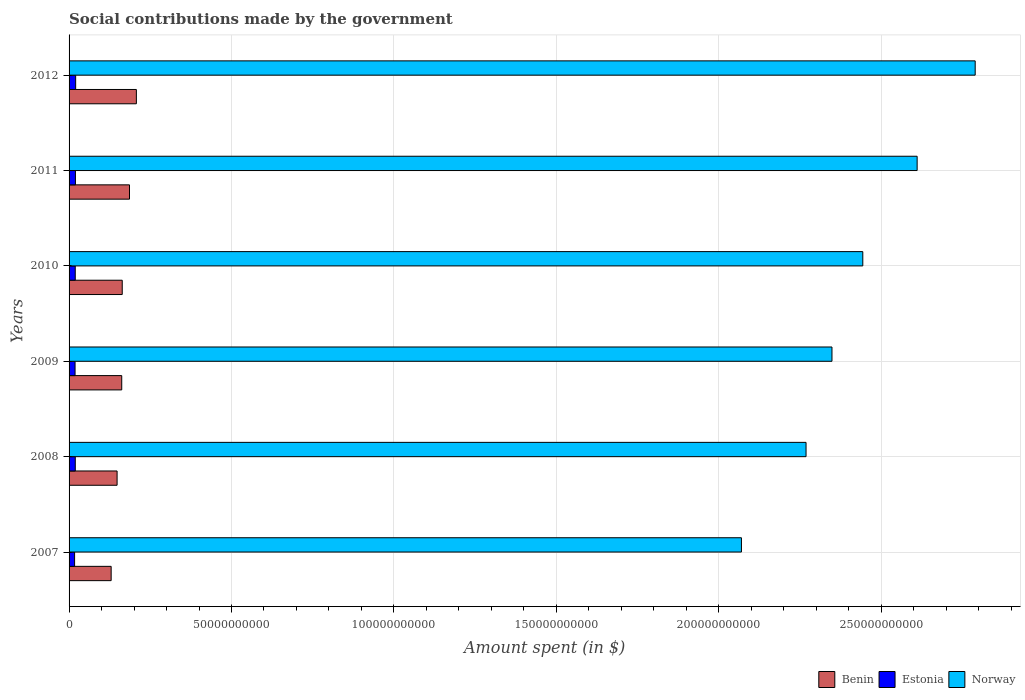Are the number of bars per tick equal to the number of legend labels?
Make the answer very short. Yes. How many bars are there on the 1st tick from the bottom?
Offer a terse response. 3. What is the amount spent on social contributions in Benin in 2007?
Provide a short and direct response. 1.30e+1. Across all years, what is the maximum amount spent on social contributions in Norway?
Your answer should be very brief. 2.79e+11. Across all years, what is the minimum amount spent on social contributions in Norway?
Your answer should be very brief. 2.07e+11. In which year was the amount spent on social contributions in Benin maximum?
Your response must be concise. 2012. What is the total amount spent on social contributions in Norway in the graph?
Ensure brevity in your answer.  1.45e+12. What is the difference between the amount spent on social contributions in Estonia in 2008 and that in 2009?
Give a very brief answer. 6.94e+07. What is the difference between the amount spent on social contributions in Norway in 2010 and the amount spent on social contributions in Estonia in 2011?
Make the answer very short. 2.42e+11. What is the average amount spent on social contributions in Benin per year?
Make the answer very short. 1.66e+1. In the year 2009, what is the difference between the amount spent on social contributions in Benin and amount spent on social contributions in Estonia?
Offer a very short reply. 1.44e+1. What is the ratio of the amount spent on social contributions in Benin in 2008 to that in 2009?
Your answer should be very brief. 0.91. Is the difference between the amount spent on social contributions in Benin in 2008 and 2010 greater than the difference between the amount spent on social contributions in Estonia in 2008 and 2010?
Your response must be concise. No. What is the difference between the highest and the second highest amount spent on social contributions in Estonia?
Your response must be concise. 6.76e+07. What is the difference between the highest and the lowest amount spent on social contributions in Benin?
Provide a succinct answer. 7.76e+09. In how many years, is the amount spent on social contributions in Estonia greater than the average amount spent on social contributions in Estonia taken over all years?
Offer a terse response. 4. Is the sum of the amount spent on social contributions in Benin in 2010 and 2011 greater than the maximum amount spent on social contributions in Norway across all years?
Offer a very short reply. No. What does the 2nd bar from the top in 2009 represents?
Your response must be concise. Estonia. How many years are there in the graph?
Your answer should be compact. 6. What is the difference between two consecutive major ticks on the X-axis?
Your answer should be very brief. 5.00e+1. Are the values on the major ticks of X-axis written in scientific E-notation?
Offer a very short reply. No. Does the graph contain any zero values?
Your response must be concise. No. How many legend labels are there?
Provide a short and direct response. 3. What is the title of the graph?
Offer a terse response. Social contributions made by the government. What is the label or title of the X-axis?
Your response must be concise. Amount spent (in $). What is the Amount spent (in $) in Benin in 2007?
Give a very brief answer. 1.30e+1. What is the Amount spent (in $) in Estonia in 2007?
Your answer should be compact. 1.70e+09. What is the Amount spent (in $) of Norway in 2007?
Make the answer very short. 2.07e+11. What is the Amount spent (in $) in Benin in 2008?
Keep it short and to the point. 1.48e+1. What is the Amount spent (in $) in Estonia in 2008?
Offer a very short reply. 1.91e+09. What is the Amount spent (in $) in Norway in 2008?
Keep it short and to the point. 2.27e+11. What is the Amount spent (in $) of Benin in 2009?
Ensure brevity in your answer.  1.62e+1. What is the Amount spent (in $) in Estonia in 2009?
Offer a terse response. 1.84e+09. What is the Amount spent (in $) of Norway in 2009?
Provide a succinct answer. 2.35e+11. What is the Amount spent (in $) in Benin in 2010?
Offer a very short reply. 1.64e+1. What is the Amount spent (in $) in Estonia in 2010?
Provide a succinct answer. 1.90e+09. What is the Amount spent (in $) of Norway in 2010?
Give a very brief answer. 2.44e+11. What is the Amount spent (in $) in Benin in 2011?
Make the answer very short. 1.86e+1. What is the Amount spent (in $) of Estonia in 2011?
Offer a terse response. 1.96e+09. What is the Amount spent (in $) of Norway in 2011?
Keep it short and to the point. 2.61e+11. What is the Amount spent (in $) of Benin in 2012?
Your answer should be compact. 2.07e+1. What is the Amount spent (in $) in Estonia in 2012?
Your answer should be very brief. 2.03e+09. What is the Amount spent (in $) of Norway in 2012?
Keep it short and to the point. 2.79e+11. Across all years, what is the maximum Amount spent (in $) of Benin?
Provide a short and direct response. 2.07e+1. Across all years, what is the maximum Amount spent (in $) of Estonia?
Offer a very short reply. 2.03e+09. Across all years, what is the maximum Amount spent (in $) of Norway?
Your answer should be compact. 2.79e+11. Across all years, what is the minimum Amount spent (in $) of Benin?
Your response must be concise. 1.30e+1. Across all years, what is the minimum Amount spent (in $) in Estonia?
Ensure brevity in your answer.  1.70e+09. Across all years, what is the minimum Amount spent (in $) in Norway?
Offer a terse response. 2.07e+11. What is the total Amount spent (in $) in Benin in the graph?
Your answer should be compact. 9.96e+1. What is the total Amount spent (in $) of Estonia in the graph?
Keep it short and to the point. 1.13e+1. What is the total Amount spent (in $) in Norway in the graph?
Ensure brevity in your answer.  1.45e+12. What is the difference between the Amount spent (in $) of Benin in 2007 and that in 2008?
Make the answer very short. -1.83e+09. What is the difference between the Amount spent (in $) of Estonia in 2007 and that in 2008?
Your answer should be compact. -2.13e+08. What is the difference between the Amount spent (in $) in Norway in 2007 and that in 2008?
Provide a short and direct response. -1.99e+1. What is the difference between the Amount spent (in $) in Benin in 2007 and that in 2009?
Provide a succinct answer. -3.26e+09. What is the difference between the Amount spent (in $) of Estonia in 2007 and that in 2009?
Offer a terse response. -1.43e+08. What is the difference between the Amount spent (in $) of Norway in 2007 and that in 2009?
Make the answer very short. -2.79e+1. What is the difference between the Amount spent (in $) in Benin in 2007 and that in 2010?
Offer a terse response. -3.41e+09. What is the difference between the Amount spent (in $) of Estonia in 2007 and that in 2010?
Provide a succinct answer. -2.05e+08. What is the difference between the Amount spent (in $) in Norway in 2007 and that in 2010?
Your answer should be very brief. -3.74e+1. What is the difference between the Amount spent (in $) of Benin in 2007 and that in 2011?
Offer a terse response. -5.65e+09. What is the difference between the Amount spent (in $) of Estonia in 2007 and that in 2011?
Your response must be concise. -2.61e+08. What is the difference between the Amount spent (in $) in Norway in 2007 and that in 2011?
Give a very brief answer. -5.41e+1. What is the difference between the Amount spent (in $) of Benin in 2007 and that in 2012?
Offer a terse response. -7.76e+09. What is the difference between the Amount spent (in $) in Estonia in 2007 and that in 2012?
Offer a terse response. -3.29e+08. What is the difference between the Amount spent (in $) in Norway in 2007 and that in 2012?
Ensure brevity in your answer.  -7.20e+1. What is the difference between the Amount spent (in $) in Benin in 2008 and that in 2009?
Ensure brevity in your answer.  -1.43e+09. What is the difference between the Amount spent (in $) of Estonia in 2008 and that in 2009?
Your answer should be compact. 6.94e+07. What is the difference between the Amount spent (in $) of Norway in 2008 and that in 2009?
Your answer should be compact. -7.98e+09. What is the difference between the Amount spent (in $) of Benin in 2008 and that in 2010?
Ensure brevity in your answer.  -1.58e+09. What is the difference between the Amount spent (in $) of Norway in 2008 and that in 2010?
Make the answer very short. -1.75e+1. What is the difference between the Amount spent (in $) in Benin in 2008 and that in 2011?
Provide a succinct answer. -3.82e+09. What is the difference between the Amount spent (in $) in Estonia in 2008 and that in 2011?
Provide a short and direct response. -4.88e+07. What is the difference between the Amount spent (in $) in Norway in 2008 and that in 2011?
Provide a succinct answer. -3.42e+1. What is the difference between the Amount spent (in $) in Benin in 2008 and that in 2012?
Your response must be concise. -5.93e+09. What is the difference between the Amount spent (in $) of Estonia in 2008 and that in 2012?
Ensure brevity in your answer.  -1.16e+08. What is the difference between the Amount spent (in $) of Norway in 2008 and that in 2012?
Your answer should be very brief. -5.21e+1. What is the difference between the Amount spent (in $) in Benin in 2009 and that in 2010?
Make the answer very short. -1.53e+08. What is the difference between the Amount spent (in $) of Estonia in 2009 and that in 2010?
Provide a succinct answer. -6.14e+07. What is the difference between the Amount spent (in $) of Norway in 2009 and that in 2010?
Offer a very short reply. -9.49e+09. What is the difference between the Amount spent (in $) in Benin in 2009 and that in 2011?
Offer a terse response. -2.39e+09. What is the difference between the Amount spent (in $) of Estonia in 2009 and that in 2011?
Offer a terse response. -1.18e+08. What is the difference between the Amount spent (in $) of Norway in 2009 and that in 2011?
Ensure brevity in your answer.  -2.62e+1. What is the difference between the Amount spent (in $) in Benin in 2009 and that in 2012?
Keep it short and to the point. -4.50e+09. What is the difference between the Amount spent (in $) in Estonia in 2009 and that in 2012?
Offer a terse response. -1.86e+08. What is the difference between the Amount spent (in $) of Norway in 2009 and that in 2012?
Your answer should be compact. -4.41e+1. What is the difference between the Amount spent (in $) of Benin in 2010 and that in 2011?
Make the answer very short. -2.24e+09. What is the difference between the Amount spent (in $) of Estonia in 2010 and that in 2011?
Your answer should be very brief. -5.68e+07. What is the difference between the Amount spent (in $) of Norway in 2010 and that in 2011?
Your answer should be compact. -1.67e+1. What is the difference between the Amount spent (in $) in Benin in 2010 and that in 2012?
Provide a succinct answer. -4.35e+09. What is the difference between the Amount spent (in $) in Estonia in 2010 and that in 2012?
Your response must be concise. -1.24e+08. What is the difference between the Amount spent (in $) in Norway in 2010 and that in 2012?
Offer a very short reply. -3.46e+1. What is the difference between the Amount spent (in $) of Benin in 2011 and that in 2012?
Your response must be concise. -2.12e+09. What is the difference between the Amount spent (in $) in Estonia in 2011 and that in 2012?
Make the answer very short. -6.76e+07. What is the difference between the Amount spent (in $) in Norway in 2011 and that in 2012?
Offer a terse response. -1.79e+1. What is the difference between the Amount spent (in $) in Benin in 2007 and the Amount spent (in $) in Estonia in 2008?
Keep it short and to the point. 1.10e+1. What is the difference between the Amount spent (in $) of Benin in 2007 and the Amount spent (in $) of Norway in 2008?
Offer a very short reply. -2.14e+11. What is the difference between the Amount spent (in $) in Estonia in 2007 and the Amount spent (in $) in Norway in 2008?
Ensure brevity in your answer.  -2.25e+11. What is the difference between the Amount spent (in $) in Benin in 2007 and the Amount spent (in $) in Estonia in 2009?
Your answer should be very brief. 1.11e+1. What is the difference between the Amount spent (in $) of Benin in 2007 and the Amount spent (in $) of Norway in 2009?
Your answer should be compact. -2.22e+11. What is the difference between the Amount spent (in $) in Estonia in 2007 and the Amount spent (in $) in Norway in 2009?
Your response must be concise. -2.33e+11. What is the difference between the Amount spent (in $) in Benin in 2007 and the Amount spent (in $) in Estonia in 2010?
Provide a succinct answer. 1.11e+1. What is the difference between the Amount spent (in $) in Benin in 2007 and the Amount spent (in $) in Norway in 2010?
Give a very brief answer. -2.31e+11. What is the difference between the Amount spent (in $) of Estonia in 2007 and the Amount spent (in $) of Norway in 2010?
Your answer should be very brief. -2.43e+11. What is the difference between the Amount spent (in $) of Benin in 2007 and the Amount spent (in $) of Estonia in 2011?
Make the answer very short. 1.10e+1. What is the difference between the Amount spent (in $) of Benin in 2007 and the Amount spent (in $) of Norway in 2011?
Offer a very short reply. -2.48e+11. What is the difference between the Amount spent (in $) in Estonia in 2007 and the Amount spent (in $) in Norway in 2011?
Provide a succinct answer. -2.59e+11. What is the difference between the Amount spent (in $) in Benin in 2007 and the Amount spent (in $) in Estonia in 2012?
Ensure brevity in your answer.  1.09e+1. What is the difference between the Amount spent (in $) in Benin in 2007 and the Amount spent (in $) in Norway in 2012?
Your response must be concise. -2.66e+11. What is the difference between the Amount spent (in $) of Estonia in 2007 and the Amount spent (in $) of Norway in 2012?
Offer a very short reply. -2.77e+11. What is the difference between the Amount spent (in $) in Benin in 2008 and the Amount spent (in $) in Estonia in 2009?
Ensure brevity in your answer.  1.29e+1. What is the difference between the Amount spent (in $) in Benin in 2008 and the Amount spent (in $) in Norway in 2009?
Offer a terse response. -2.20e+11. What is the difference between the Amount spent (in $) of Estonia in 2008 and the Amount spent (in $) of Norway in 2009?
Keep it short and to the point. -2.33e+11. What is the difference between the Amount spent (in $) of Benin in 2008 and the Amount spent (in $) of Estonia in 2010?
Give a very brief answer. 1.29e+1. What is the difference between the Amount spent (in $) in Benin in 2008 and the Amount spent (in $) in Norway in 2010?
Provide a short and direct response. -2.30e+11. What is the difference between the Amount spent (in $) of Estonia in 2008 and the Amount spent (in $) of Norway in 2010?
Ensure brevity in your answer.  -2.42e+11. What is the difference between the Amount spent (in $) of Benin in 2008 and the Amount spent (in $) of Estonia in 2011?
Give a very brief answer. 1.28e+1. What is the difference between the Amount spent (in $) in Benin in 2008 and the Amount spent (in $) in Norway in 2011?
Provide a succinct answer. -2.46e+11. What is the difference between the Amount spent (in $) in Estonia in 2008 and the Amount spent (in $) in Norway in 2011?
Ensure brevity in your answer.  -2.59e+11. What is the difference between the Amount spent (in $) in Benin in 2008 and the Amount spent (in $) in Estonia in 2012?
Your answer should be very brief. 1.28e+1. What is the difference between the Amount spent (in $) in Benin in 2008 and the Amount spent (in $) in Norway in 2012?
Offer a terse response. -2.64e+11. What is the difference between the Amount spent (in $) in Estonia in 2008 and the Amount spent (in $) in Norway in 2012?
Keep it short and to the point. -2.77e+11. What is the difference between the Amount spent (in $) in Benin in 2009 and the Amount spent (in $) in Estonia in 2010?
Provide a short and direct response. 1.43e+1. What is the difference between the Amount spent (in $) in Benin in 2009 and the Amount spent (in $) in Norway in 2010?
Provide a succinct answer. -2.28e+11. What is the difference between the Amount spent (in $) in Estonia in 2009 and the Amount spent (in $) in Norway in 2010?
Your answer should be compact. -2.42e+11. What is the difference between the Amount spent (in $) in Benin in 2009 and the Amount spent (in $) in Estonia in 2011?
Your answer should be very brief. 1.43e+1. What is the difference between the Amount spent (in $) of Benin in 2009 and the Amount spent (in $) of Norway in 2011?
Your answer should be compact. -2.45e+11. What is the difference between the Amount spent (in $) in Estonia in 2009 and the Amount spent (in $) in Norway in 2011?
Provide a succinct answer. -2.59e+11. What is the difference between the Amount spent (in $) in Benin in 2009 and the Amount spent (in $) in Estonia in 2012?
Offer a very short reply. 1.42e+1. What is the difference between the Amount spent (in $) in Benin in 2009 and the Amount spent (in $) in Norway in 2012?
Your answer should be compact. -2.63e+11. What is the difference between the Amount spent (in $) in Estonia in 2009 and the Amount spent (in $) in Norway in 2012?
Your answer should be very brief. -2.77e+11. What is the difference between the Amount spent (in $) of Benin in 2010 and the Amount spent (in $) of Estonia in 2011?
Provide a succinct answer. 1.44e+1. What is the difference between the Amount spent (in $) of Benin in 2010 and the Amount spent (in $) of Norway in 2011?
Ensure brevity in your answer.  -2.45e+11. What is the difference between the Amount spent (in $) in Estonia in 2010 and the Amount spent (in $) in Norway in 2011?
Keep it short and to the point. -2.59e+11. What is the difference between the Amount spent (in $) of Benin in 2010 and the Amount spent (in $) of Estonia in 2012?
Provide a succinct answer. 1.43e+1. What is the difference between the Amount spent (in $) of Benin in 2010 and the Amount spent (in $) of Norway in 2012?
Offer a terse response. -2.63e+11. What is the difference between the Amount spent (in $) of Estonia in 2010 and the Amount spent (in $) of Norway in 2012?
Give a very brief answer. -2.77e+11. What is the difference between the Amount spent (in $) of Benin in 2011 and the Amount spent (in $) of Estonia in 2012?
Your answer should be compact. 1.66e+1. What is the difference between the Amount spent (in $) of Benin in 2011 and the Amount spent (in $) of Norway in 2012?
Offer a very short reply. -2.60e+11. What is the difference between the Amount spent (in $) of Estonia in 2011 and the Amount spent (in $) of Norway in 2012?
Your answer should be very brief. -2.77e+11. What is the average Amount spent (in $) of Benin per year?
Offer a very short reply. 1.66e+1. What is the average Amount spent (in $) of Estonia per year?
Give a very brief answer. 1.89e+09. What is the average Amount spent (in $) in Norway per year?
Your answer should be very brief. 2.42e+11. In the year 2007, what is the difference between the Amount spent (in $) of Benin and Amount spent (in $) of Estonia?
Offer a very short reply. 1.13e+1. In the year 2007, what is the difference between the Amount spent (in $) in Benin and Amount spent (in $) in Norway?
Your answer should be very brief. -1.94e+11. In the year 2007, what is the difference between the Amount spent (in $) in Estonia and Amount spent (in $) in Norway?
Your answer should be very brief. -2.05e+11. In the year 2008, what is the difference between the Amount spent (in $) in Benin and Amount spent (in $) in Estonia?
Your response must be concise. 1.29e+1. In the year 2008, what is the difference between the Amount spent (in $) in Benin and Amount spent (in $) in Norway?
Make the answer very short. -2.12e+11. In the year 2008, what is the difference between the Amount spent (in $) of Estonia and Amount spent (in $) of Norway?
Ensure brevity in your answer.  -2.25e+11. In the year 2009, what is the difference between the Amount spent (in $) of Benin and Amount spent (in $) of Estonia?
Your answer should be compact. 1.44e+1. In the year 2009, what is the difference between the Amount spent (in $) in Benin and Amount spent (in $) in Norway?
Give a very brief answer. -2.19e+11. In the year 2009, what is the difference between the Amount spent (in $) in Estonia and Amount spent (in $) in Norway?
Make the answer very short. -2.33e+11. In the year 2010, what is the difference between the Amount spent (in $) in Benin and Amount spent (in $) in Estonia?
Ensure brevity in your answer.  1.45e+1. In the year 2010, what is the difference between the Amount spent (in $) of Benin and Amount spent (in $) of Norway?
Provide a short and direct response. -2.28e+11. In the year 2010, what is the difference between the Amount spent (in $) of Estonia and Amount spent (in $) of Norway?
Give a very brief answer. -2.42e+11. In the year 2011, what is the difference between the Amount spent (in $) of Benin and Amount spent (in $) of Estonia?
Your response must be concise. 1.66e+1. In the year 2011, what is the difference between the Amount spent (in $) of Benin and Amount spent (in $) of Norway?
Ensure brevity in your answer.  -2.42e+11. In the year 2011, what is the difference between the Amount spent (in $) in Estonia and Amount spent (in $) in Norway?
Your response must be concise. -2.59e+11. In the year 2012, what is the difference between the Amount spent (in $) in Benin and Amount spent (in $) in Estonia?
Ensure brevity in your answer.  1.87e+1. In the year 2012, what is the difference between the Amount spent (in $) in Benin and Amount spent (in $) in Norway?
Your response must be concise. -2.58e+11. In the year 2012, what is the difference between the Amount spent (in $) in Estonia and Amount spent (in $) in Norway?
Keep it short and to the point. -2.77e+11. What is the ratio of the Amount spent (in $) of Benin in 2007 to that in 2008?
Your answer should be very brief. 0.88. What is the ratio of the Amount spent (in $) of Estonia in 2007 to that in 2008?
Make the answer very short. 0.89. What is the ratio of the Amount spent (in $) of Norway in 2007 to that in 2008?
Make the answer very short. 0.91. What is the ratio of the Amount spent (in $) of Benin in 2007 to that in 2009?
Offer a very short reply. 0.8. What is the ratio of the Amount spent (in $) in Estonia in 2007 to that in 2009?
Your answer should be very brief. 0.92. What is the ratio of the Amount spent (in $) of Norway in 2007 to that in 2009?
Give a very brief answer. 0.88. What is the ratio of the Amount spent (in $) in Benin in 2007 to that in 2010?
Provide a succinct answer. 0.79. What is the ratio of the Amount spent (in $) of Estonia in 2007 to that in 2010?
Your answer should be very brief. 0.89. What is the ratio of the Amount spent (in $) in Norway in 2007 to that in 2010?
Keep it short and to the point. 0.85. What is the ratio of the Amount spent (in $) of Benin in 2007 to that in 2011?
Your answer should be very brief. 0.7. What is the ratio of the Amount spent (in $) in Estonia in 2007 to that in 2011?
Give a very brief answer. 0.87. What is the ratio of the Amount spent (in $) in Norway in 2007 to that in 2011?
Your answer should be compact. 0.79. What is the ratio of the Amount spent (in $) of Benin in 2007 to that in 2012?
Ensure brevity in your answer.  0.63. What is the ratio of the Amount spent (in $) in Estonia in 2007 to that in 2012?
Keep it short and to the point. 0.84. What is the ratio of the Amount spent (in $) in Norway in 2007 to that in 2012?
Give a very brief answer. 0.74. What is the ratio of the Amount spent (in $) in Benin in 2008 to that in 2009?
Offer a very short reply. 0.91. What is the ratio of the Amount spent (in $) of Estonia in 2008 to that in 2009?
Your answer should be very brief. 1.04. What is the ratio of the Amount spent (in $) in Benin in 2008 to that in 2010?
Provide a succinct answer. 0.9. What is the ratio of the Amount spent (in $) in Estonia in 2008 to that in 2010?
Offer a very short reply. 1. What is the ratio of the Amount spent (in $) of Norway in 2008 to that in 2010?
Offer a very short reply. 0.93. What is the ratio of the Amount spent (in $) in Benin in 2008 to that in 2011?
Offer a very short reply. 0.79. What is the ratio of the Amount spent (in $) of Estonia in 2008 to that in 2011?
Ensure brevity in your answer.  0.98. What is the ratio of the Amount spent (in $) of Norway in 2008 to that in 2011?
Provide a succinct answer. 0.87. What is the ratio of the Amount spent (in $) of Benin in 2008 to that in 2012?
Offer a very short reply. 0.71. What is the ratio of the Amount spent (in $) of Estonia in 2008 to that in 2012?
Provide a short and direct response. 0.94. What is the ratio of the Amount spent (in $) of Norway in 2008 to that in 2012?
Give a very brief answer. 0.81. What is the ratio of the Amount spent (in $) of Benin in 2009 to that in 2010?
Keep it short and to the point. 0.99. What is the ratio of the Amount spent (in $) of Estonia in 2009 to that in 2010?
Provide a short and direct response. 0.97. What is the ratio of the Amount spent (in $) of Norway in 2009 to that in 2010?
Offer a terse response. 0.96. What is the ratio of the Amount spent (in $) of Benin in 2009 to that in 2011?
Offer a very short reply. 0.87. What is the ratio of the Amount spent (in $) in Estonia in 2009 to that in 2011?
Make the answer very short. 0.94. What is the ratio of the Amount spent (in $) of Norway in 2009 to that in 2011?
Offer a very short reply. 0.9. What is the ratio of the Amount spent (in $) in Benin in 2009 to that in 2012?
Keep it short and to the point. 0.78. What is the ratio of the Amount spent (in $) in Estonia in 2009 to that in 2012?
Make the answer very short. 0.91. What is the ratio of the Amount spent (in $) of Norway in 2009 to that in 2012?
Your answer should be very brief. 0.84. What is the ratio of the Amount spent (in $) in Benin in 2010 to that in 2011?
Ensure brevity in your answer.  0.88. What is the ratio of the Amount spent (in $) of Norway in 2010 to that in 2011?
Offer a terse response. 0.94. What is the ratio of the Amount spent (in $) of Benin in 2010 to that in 2012?
Make the answer very short. 0.79. What is the ratio of the Amount spent (in $) of Estonia in 2010 to that in 2012?
Provide a succinct answer. 0.94. What is the ratio of the Amount spent (in $) of Norway in 2010 to that in 2012?
Give a very brief answer. 0.88. What is the ratio of the Amount spent (in $) of Benin in 2011 to that in 2012?
Your answer should be compact. 0.9. What is the ratio of the Amount spent (in $) of Estonia in 2011 to that in 2012?
Make the answer very short. 0.97. What is the ratio of the Amount spent (in $) of Norway in 2011 to that in 2012?
Offer a terse response. 0.94. What is the difference between the highest and the second highest Amount spent (in $) of Benin?
Offer a very short reply. 2.12e+09. What is the difference between the highest and the second highest Amount spent (in $) in Estonia?
Provide a succinct answer. 6.76e+07. What is the difference between the highest and the second highest Amount spent (in $) of Norway?
Ensure brevity in your answer.  1.79e+1. What is the difference between the highest and the lowest Amount spent (in $) in Benin?
Your answer should be very brief. 7.76e+09. What is the difference between the highest and the lowest Amount spent (in $) in Estonia?
Your answer should be very brief. 3.29e+08. What is the difference between the highest and the lowest Amount spent (in $) in Norway?
Your answer should be compact. 7.20e+1. 